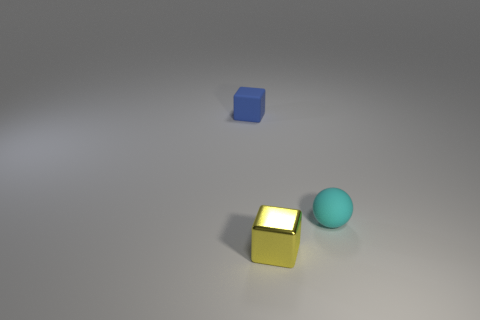What number of other shiny things are the same shape as the small blue object?
Offer a terse response. 1. What size is the blue thing that is made of the same material as the tiny cyan thing?
Your response must be concise. Small. What is the shape of the matte thing on the right side of the block that is to the right of the small thing that is behind the small sphere?
Your response must be concise. Sphere. Are there the same number of small things that are on the left side of the small blue rubber block and yellow blocks?
Your answer should be compact. No. Is the blue rubber thing the same shape as the tiny cyan rubber thing?
Your answer should be very brief. No. How many objects are either matte objects left of the ball or small red cubes?
Provide a succinct answer. 1. Are there the same number of yellow metallic blocks left of the tiny cyan rubber object and cyan matte spheres in front of the tiny yellow cube?
Your response must be concise. No. What number of other things are the same shape as the cyan object?
Offer a terse response. 0. Is the size of the matte thing that is on the left side of the yellow object the same as the cyan matte sphere that is behind the small yellow thing?
Provide a succinct answer. Yes. What number of blocks are yellow objects or tiny blue rubber objects?
Offer a very short reply. 2. 